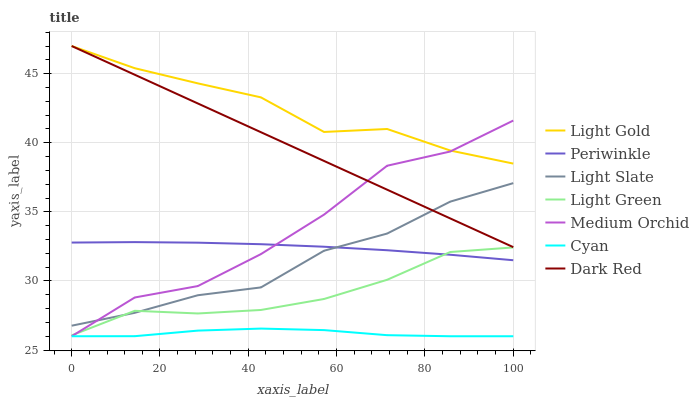Does Cyan have the minimum area under the curve?
Answer yes or no. Yes. Does Light Gold have the maximum area under the curve?
Answer yes or no. Yes. Does Dark Red have the minimum area under the curve?
Answer yes or no. No. Does Dark Red have the maximum area under the curve?
Answer yes or no. No. Is Dark Red the smoothest?
Answer yes or no. Yes. Is Medium Orchid the roughest?
Answer yes or no. Yes. Is Medium Orchid the smoothest?
Answer yes or no. No. Is Dark Red the roughest?
Answer yes or no. No. Does Cyan have the lowest value?
Answer yes or no. Yes. Does Dark Red have the lowest value?
Answer yes or no. No. Does Light Gold have the highest value?
Answer yes or no. Yes. Does Medium Orchid have the highest value?
Answer yes or no. No. Is Light Green less than Dark Red?
Answer yes or no. Yes. Is Dark Red greater than Cyan?
Answer yes or no. Yes. Does Light Gold intersect Dark Red?
Answer yes or no. Yes. Is Light Gold less than Dark Red?
Answer yes or no. No. Is Light Gold greater than Dark Red?
Answer yes or no. No. Does Light Green intersect Dark Red?
Answer yes or no. No. 